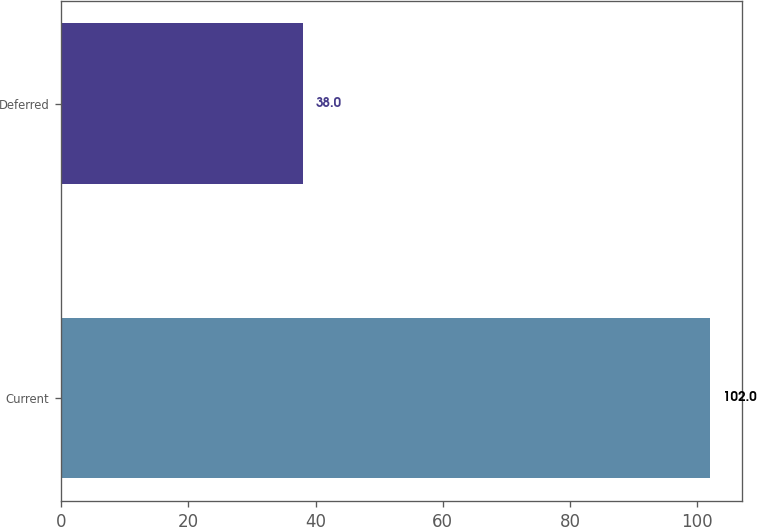Convert chart to OTSL. <chart><loc_0><loc_0><loc_500><loc_500><bar_chart><fcel>Current<fcel>Deferred<nl><fcel>102<fcel>38<nl></chart> 